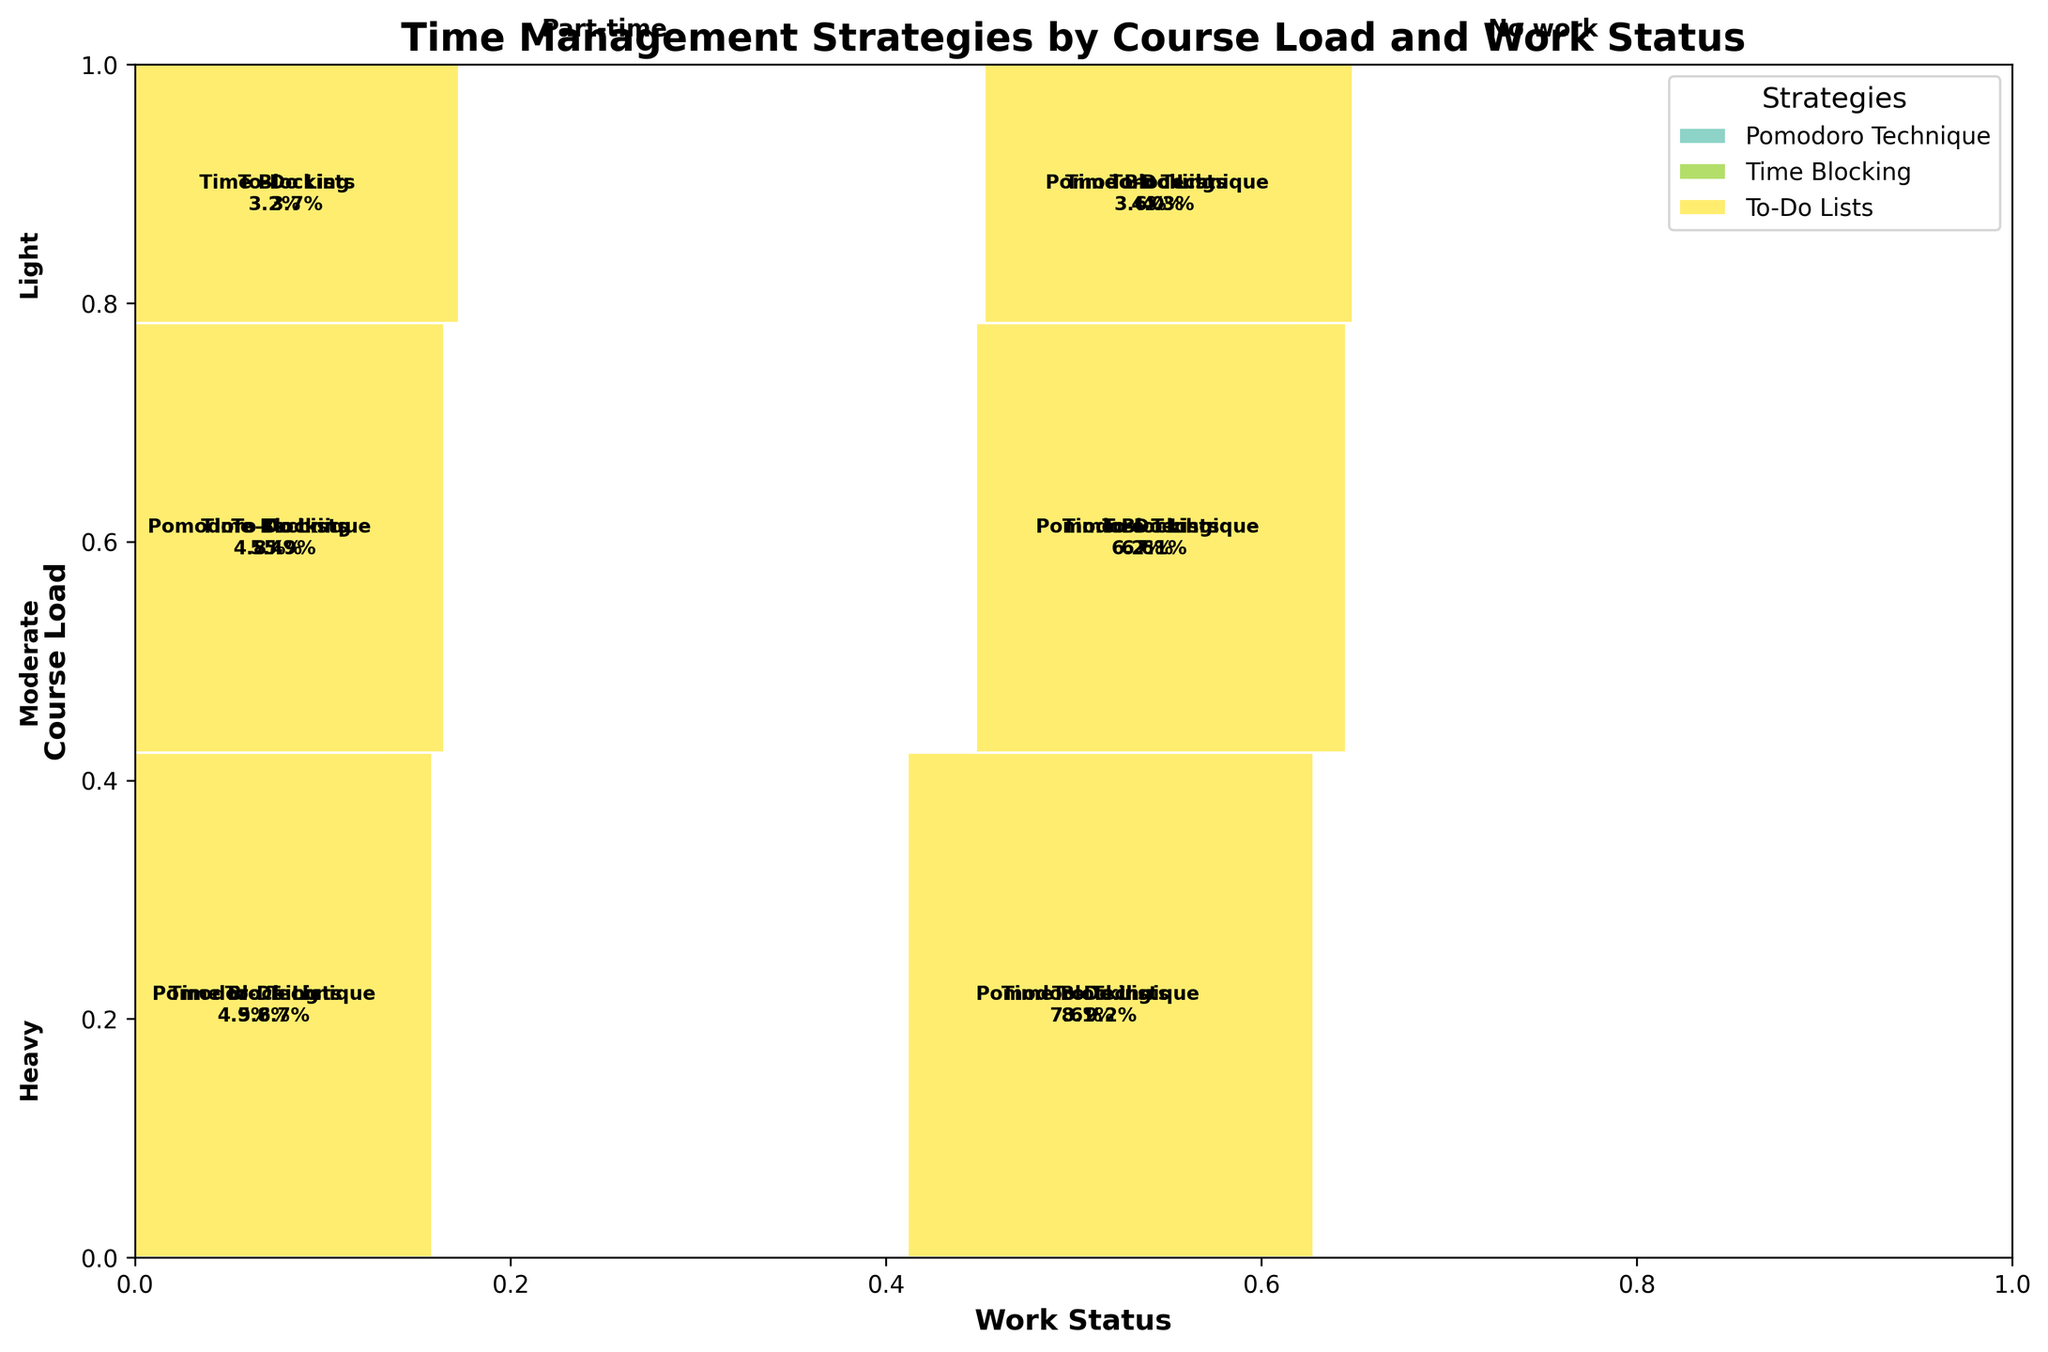What is the most commonly used time management strategy for students with a heavy course load and no work? By examining the sections of the figure corresponding to students with a heavy course load and no work, we can see which time management strategy area is the largest.
Answer: To-Do Lists Which combination of course load and work status utilizes the Pomodoro Technique the least? To find this, look at all the sections in the figure pertaining to the Pomodoro Technique and determine which combination of course load and work status has the smallest area.
Answer: Light course load and part-time work How do the proportions of students using Time Blocking change between those with a moderate course load and part-time work versus no work? Compare the sizes of the Time Blocking sections for students with a moderate course load in both part-time work and no work categories.
Answer: Larger for students with no work What is the total proportion of students who use To-Do Lists regardless of course load and work status? Add the proportions of all sections related to the use of To-Do Lists displayed in the figure.
Answer: 0.275 Comparing students with a light course load, does working part-time affect the use of Time Blocking? Examine the Time Blocking sections for students with a light course load and compare their sizes between the part-time and no work categories.
Answer: Yes, part-time work reduces it Among students with a moderate course load, which time management strategy is least popular? Assess the sizes of the sections for students with a moderate course load for each time management strategy and identify the smallest one.
Answer: Pomodoro Technique What time management strategy is used by students with a heavy course load and part-time work to the greatest extent? Look at the sections for students with a heavy course load and part-time work to see which strategy occupies the largest area.
Answer: To-Do Lists How does the use of To-Do Lists differ between students with a heavy course load and those with a light course load? Compare the sizes of the To-Do Lists sections for students with heavy and light course loads.
Answer: More used by students with a heavy course load 